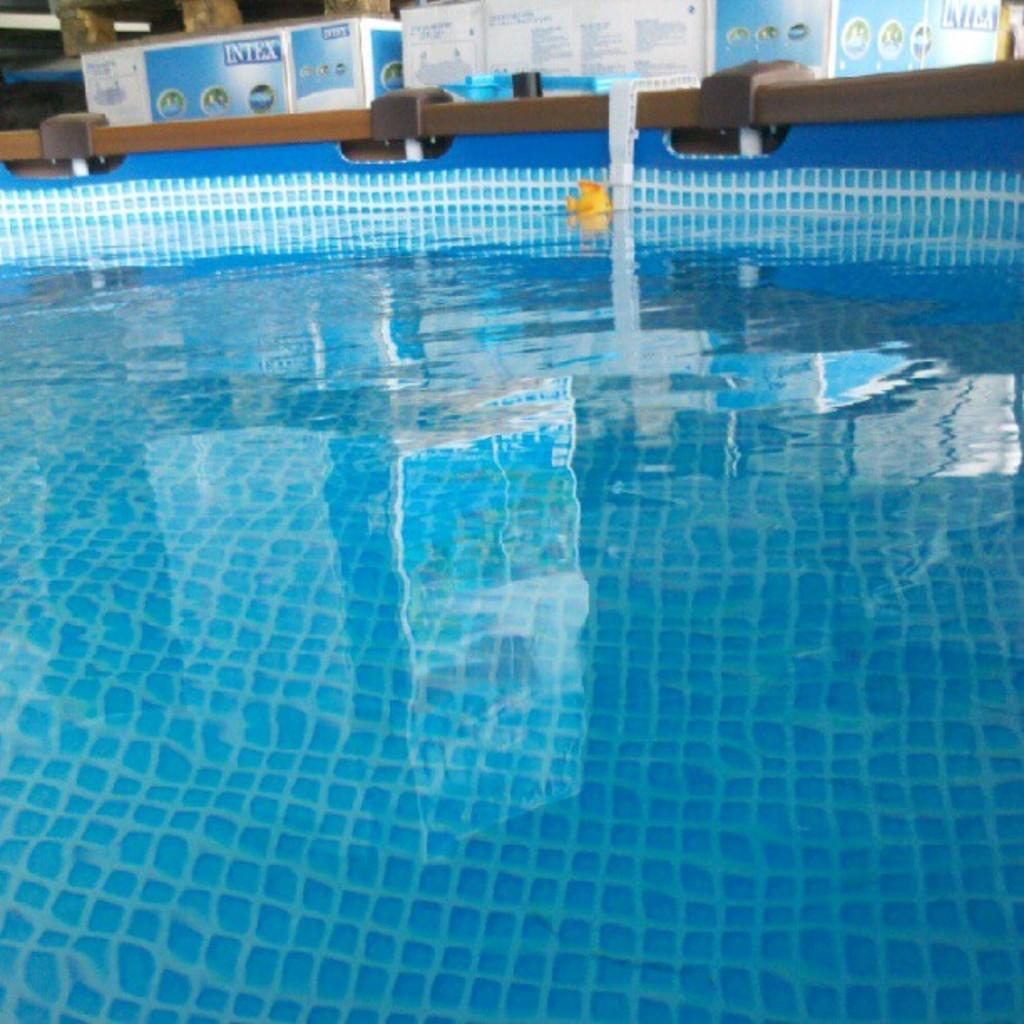What is the main feature in the image? There is a pool in the image. Can you describe anything else visible in the background? There are boxes in the background of the image. What type of trousers can be seen hanging on the edge of the pool in the image? There are no trousers visible in the image; it only features a pool and boxes in the background. 